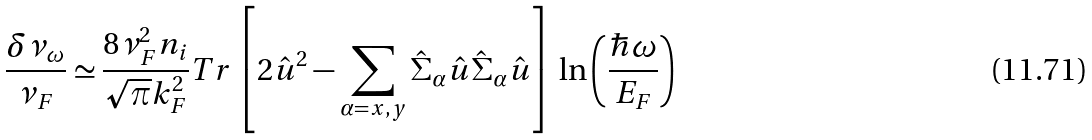Convert formula to latex. <formula><loc_0><loc_0><loc_500><loc_500>\frac { \delta \nu _ { \omega } } { \nu _ { F } } \simeq \frac { 8 \nu _ { F } ^ { 2 } n _ { i } } { \sqrt { \pi } k ^ { 2 } _ { F } } T r \left [ 2 \hat { u } ^ { 2 } - \sum _ { \alpha = x , y } \hat { \Sigma } _ { \alpha } \hat { u } \hat { \Sigma } _ { \alpha } \hat { u } \right ] \, \ln \left ( \frac { \hbar { \omega } } { E _ { F } } \right )</formula> 